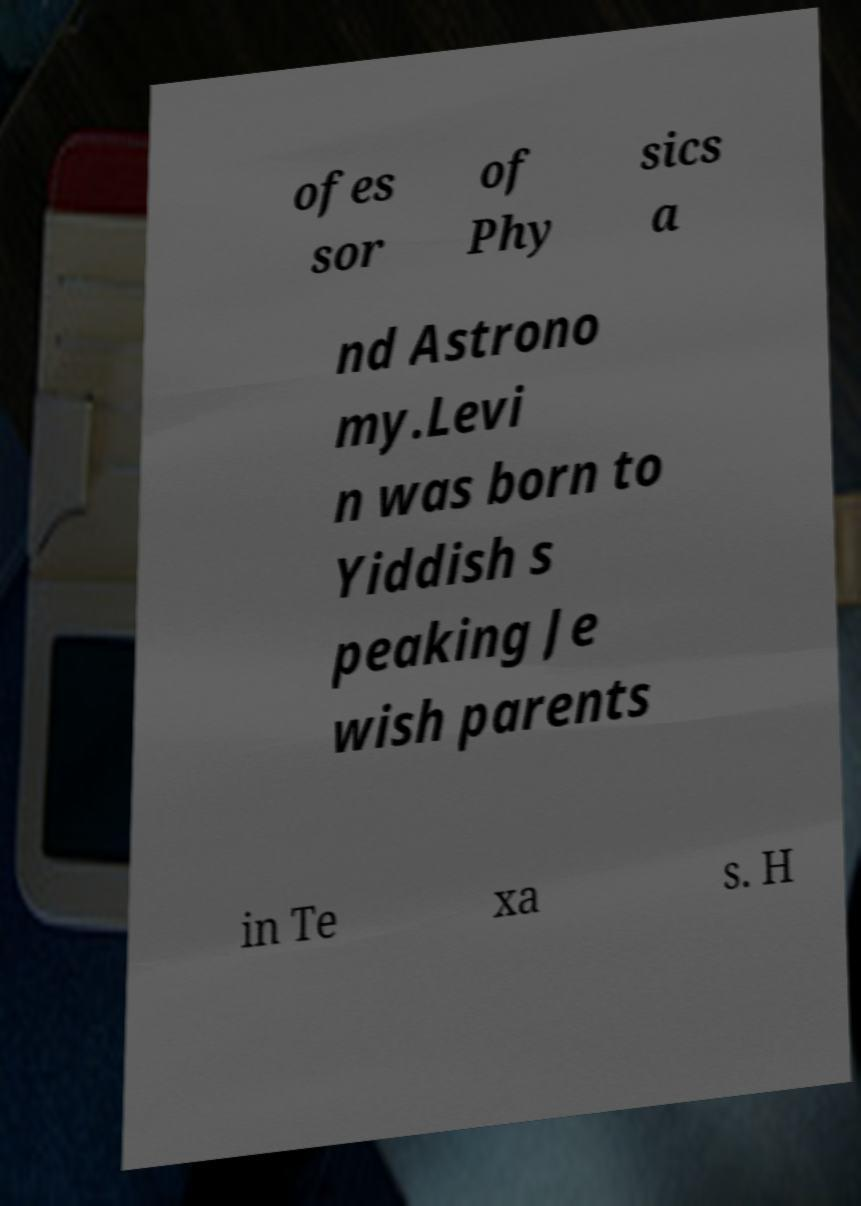Can you accurately transcribe the text from the provided image for me? ofes sor of Phy sics a nd Astrono my.Levi n was born to Yiddish s peaking Je wish parents in Te xa s. H 